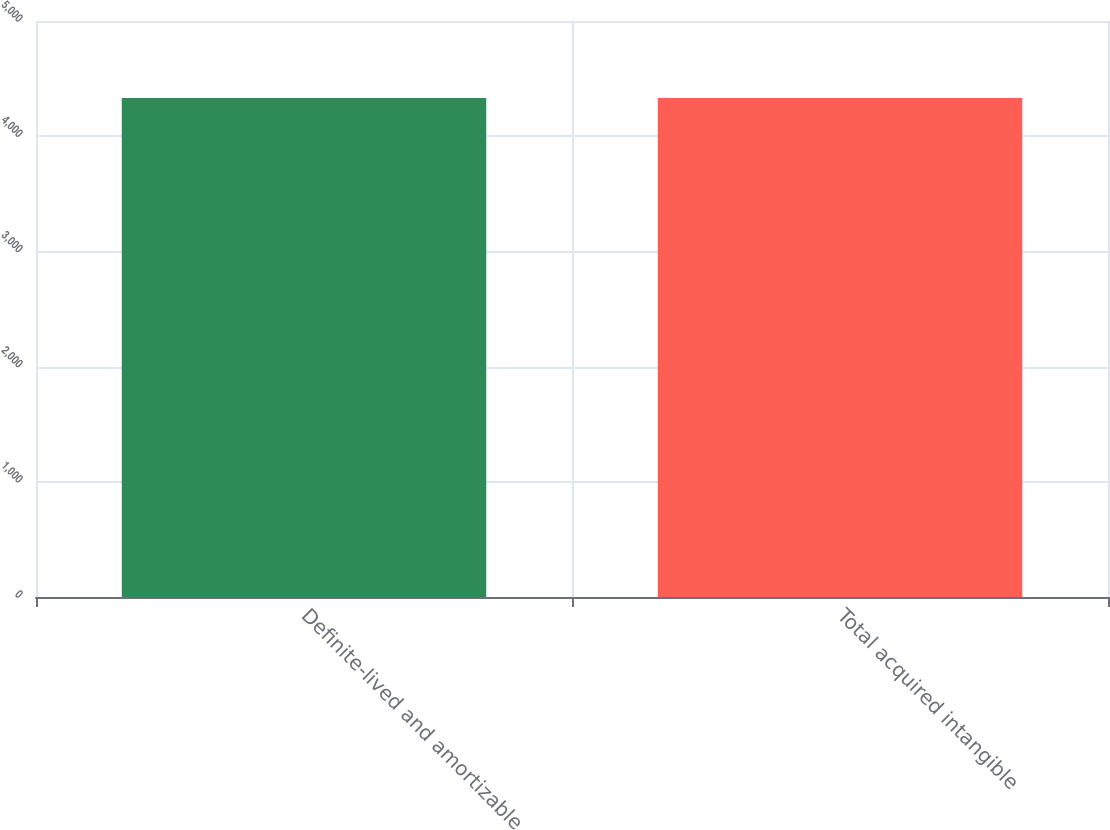<chart> <loc_0><loc_0><loc_500><loc_500><bar_chart><fcel>Definite-lived and amortizable<fcel>Total acquired intangible<nl><fcel>4332<fcel>4332.1<nl></chart> 